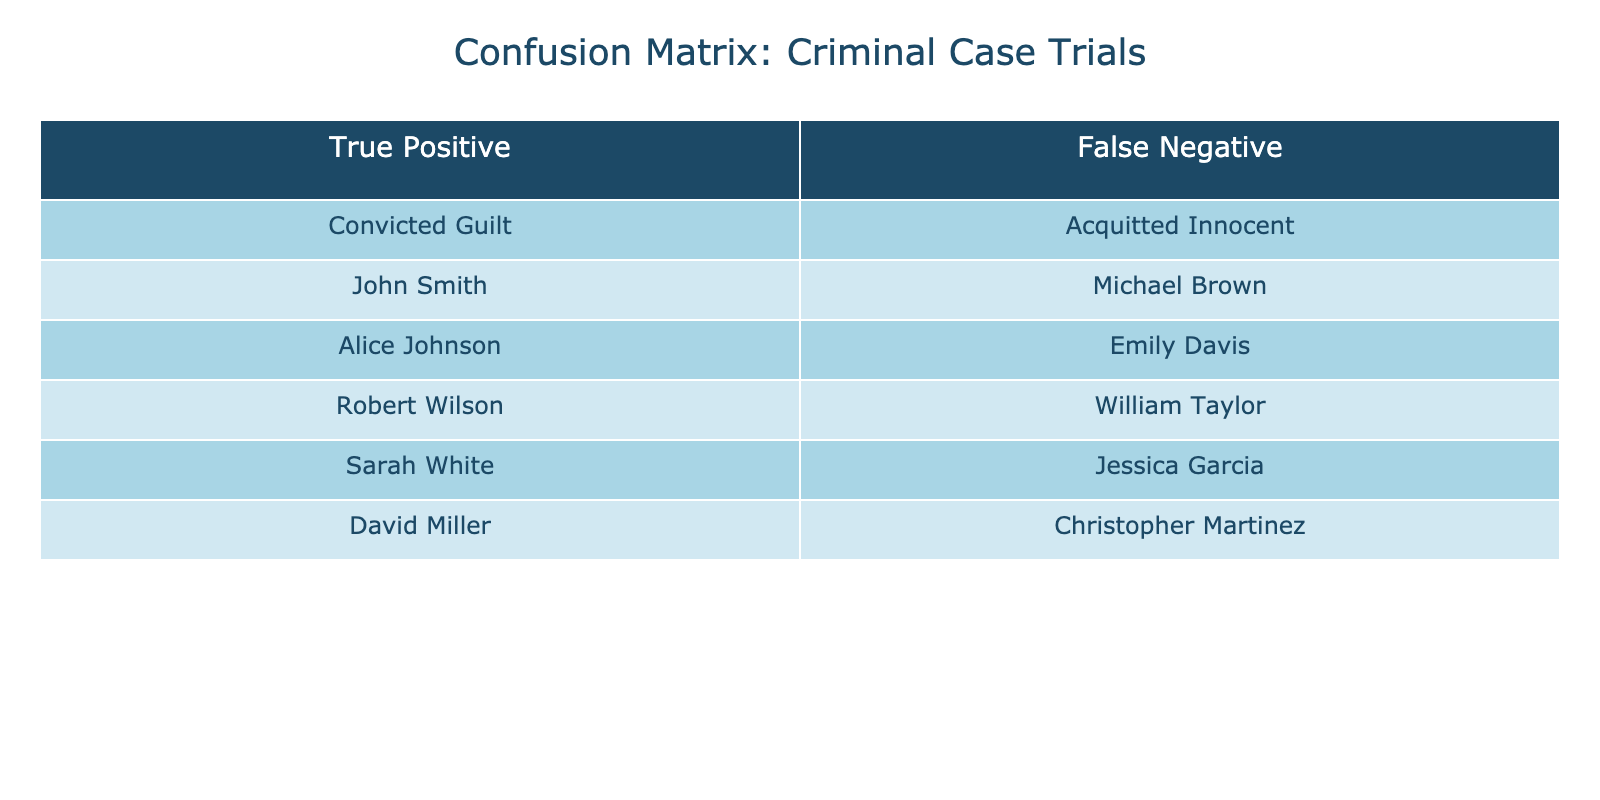What are the names listed under True Positive? The names listed in the True Positive column are John Smith, Alice Johnson, Robert Wilson, Sarah White, and David Miller.
Answer: John Smith, Alice Johnson, Robert Wilson, Sarah White, David Miller How many individuals were acquitted? The Acquitted Innocent column contains five names: Michael Brown, Emily Davis, William Taylor, Jessica Garcia, and Christopher Martinez, which totals to five individuals.
Answer: 5 Is David Miller included in the False Negative category? David Miller is listed under the True Positive column, so he is not included in the False Negative category.
Answer: No What is the total number of individuals in the confusion matrix table? The table lists five individuals under True Positives and five under False Negatives. Therefore, the total number of individuals is 5 + 5 = 10.
Answer: 10 Which individual is not guilty but was acquitted? The individuals in the False Negative category represent those who were acquitted, meaning they are not guilty. From the table, the acquitted individuals are Michael Brown, Emily Davis, William Taylor, Jessica Garcia, and Christopher Martinez.
Answer: Michael Brown, Emily Davis, William Taylor, Jessica Garcia, Christopher Martinez How many more individuals are guilty (convicted) than innocent (acquitted)? There are 5 individuals convicted under True Positive and 5 acquitted under False Negative. The difference is 5 - 5 = 0, meaning there is no difference in the count.
Answer: 0 Is Sarah White considered innocent according to the confusion matrix? Sarah White is listed in the True Positive category, indicating that she has been convicted, thus she is not considered innocent.
Answer: No What percentage of individuals in the table were convicted? There are 5 individuals convicted (True Positive) out of 10 total individuals. So, the percentage is (5/10) * 100 = 50%.
Answer: 50% 